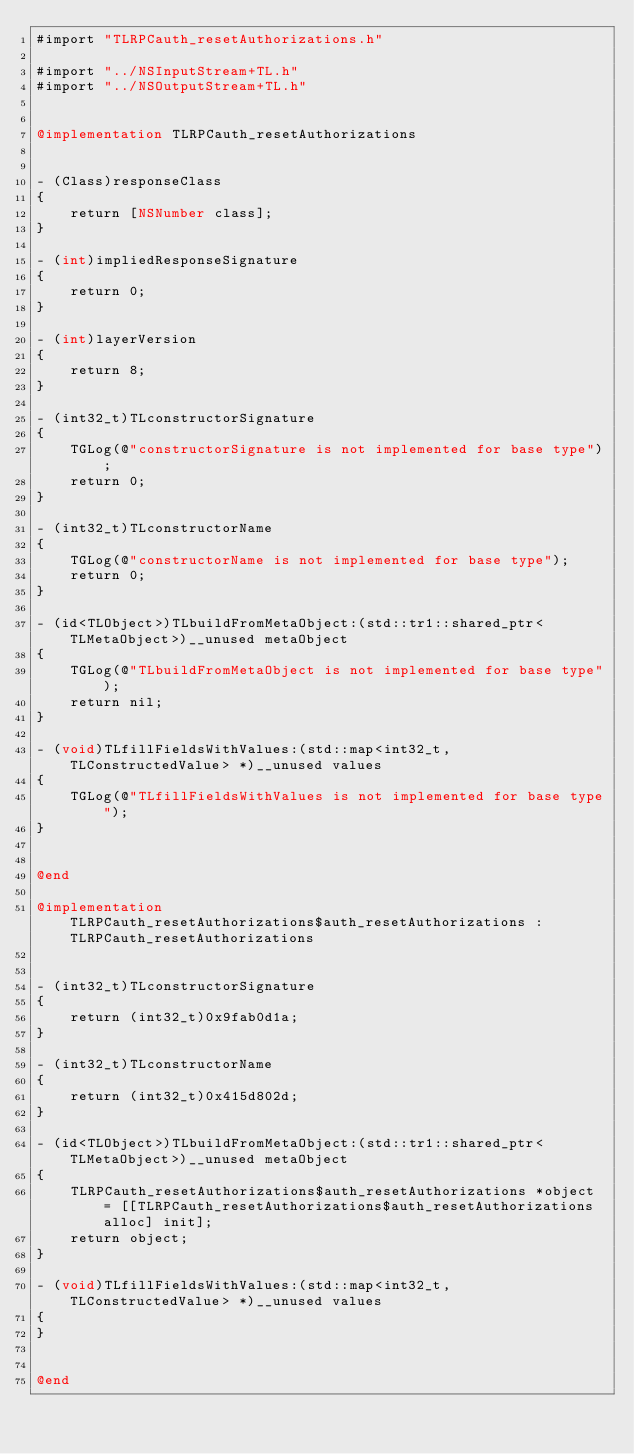<code> <loc_0><loc_0><loc_500><loc_500><_ObjectiveC_>#import "TLRPCauth_resetAuthorizations.h"

#import "../NSInputStream+TL.h"
#import "../NSOutputStream+TL.h"


@implementation TLRPCauth_resetAuthorizations


- (Class)responseClass
{
    return [NSNumber class];
}

- (int)impliedResponseSignature
{
    return 0;
}

- (int)layerVersion
{
    return 8;
}

- (int32_t)TLconstructorSignature
{
    TGLog(@"constructorSignature is not implemented for base type");
    return 0;
}

- (int32_t)TLconstructorName
{
    TGLog(@"constructorName is not implemented for base type");
    return 0;
}

- (id<TLObject>)TLbuildFromMetaObject:(std::tr1::shared_ptr<TLMetaObject>)__unused metaObject
{
    TGLog(@"TLbuildFromMetaObject is not implemented for base type");
    return nil;
}

- (void)TLfillFieldsWithValues:(std::map<int32_t, TLConstructedValue> *)__unused values
{
    TGLog(@"TLfillFieldsWithValues is not implemented for base type");
}


@end

@implementation TLRPCauth_resetAuthorizations$auth_resetAuthorizations : TLRPCauth_resetAuthorizations


- (int32_t)TLconstructorSignature
{
    return (int32_t)0x9fab0d1a;
}

- (int32_t)TLconstructorName
{
    return (int32_t)0x415d802d;
}

- (id<TLObject>)TLbuildFromMetaObject:(std::tr1::shared_ptr<TLMetaObject>)__unused metaObject
{
    TLRPCauth_resetAuthorizations$auth_resetAuthorizations *object = [[TLRPCauth_resetAuthorizations$auth_resetAuthorizations alloc] init];
    return object;
}

- (void)TLfillFieldsWithValues:(std::map<int32_t, TLConstructedValue> *)__unused values
{
}


@end

</code> 